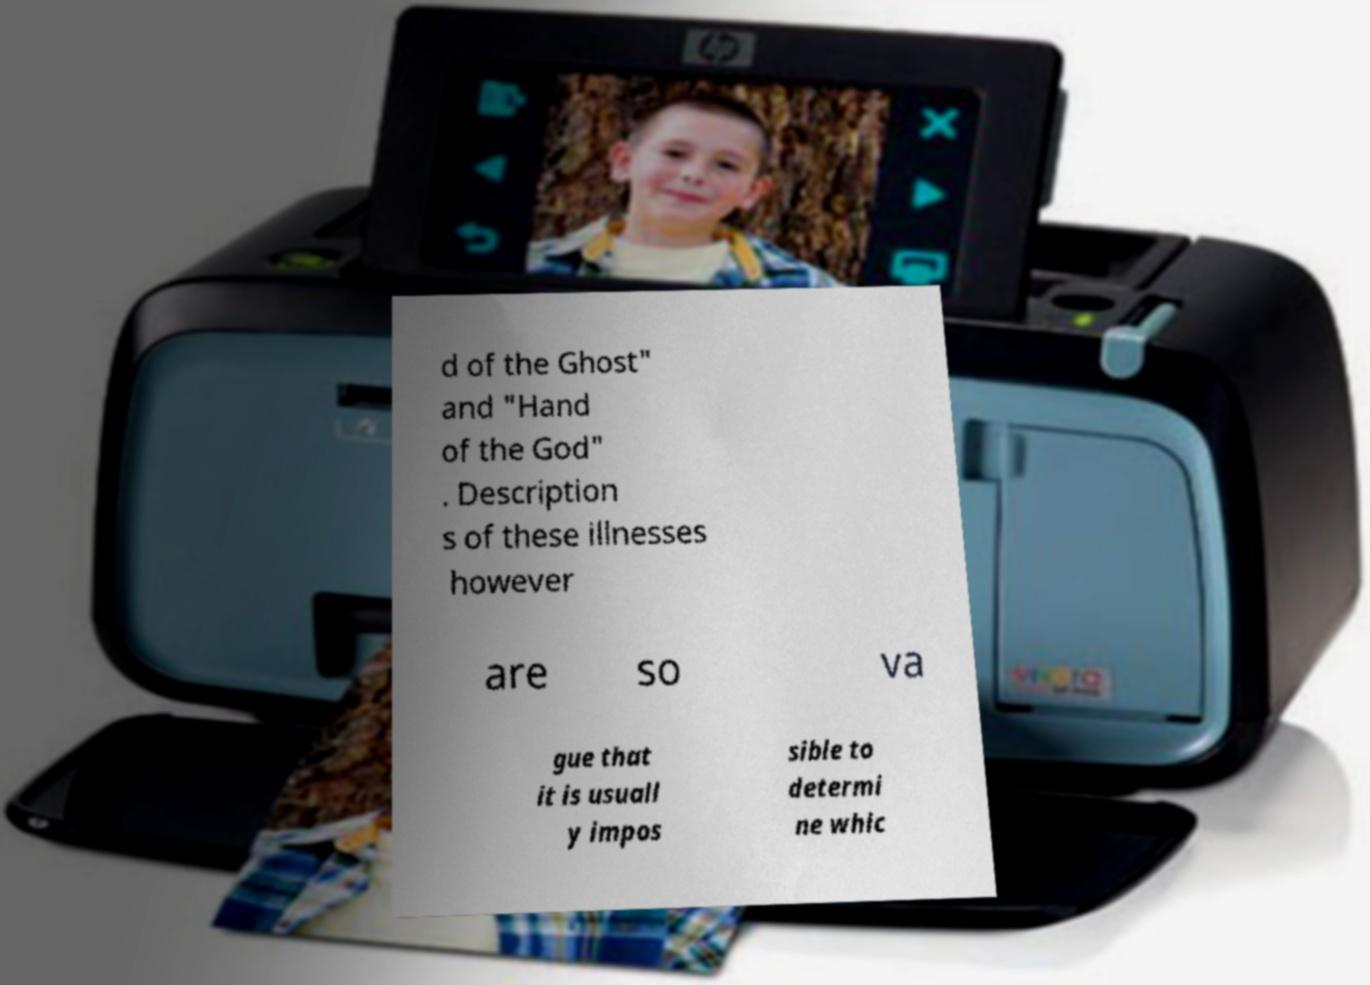Can you accurately transcribe the text from the provided image for me? d of the Ghost" and "Hand of the God" . Description s of these illnesses however are so va gue that it is usuall y impos sible to determi ne whic 